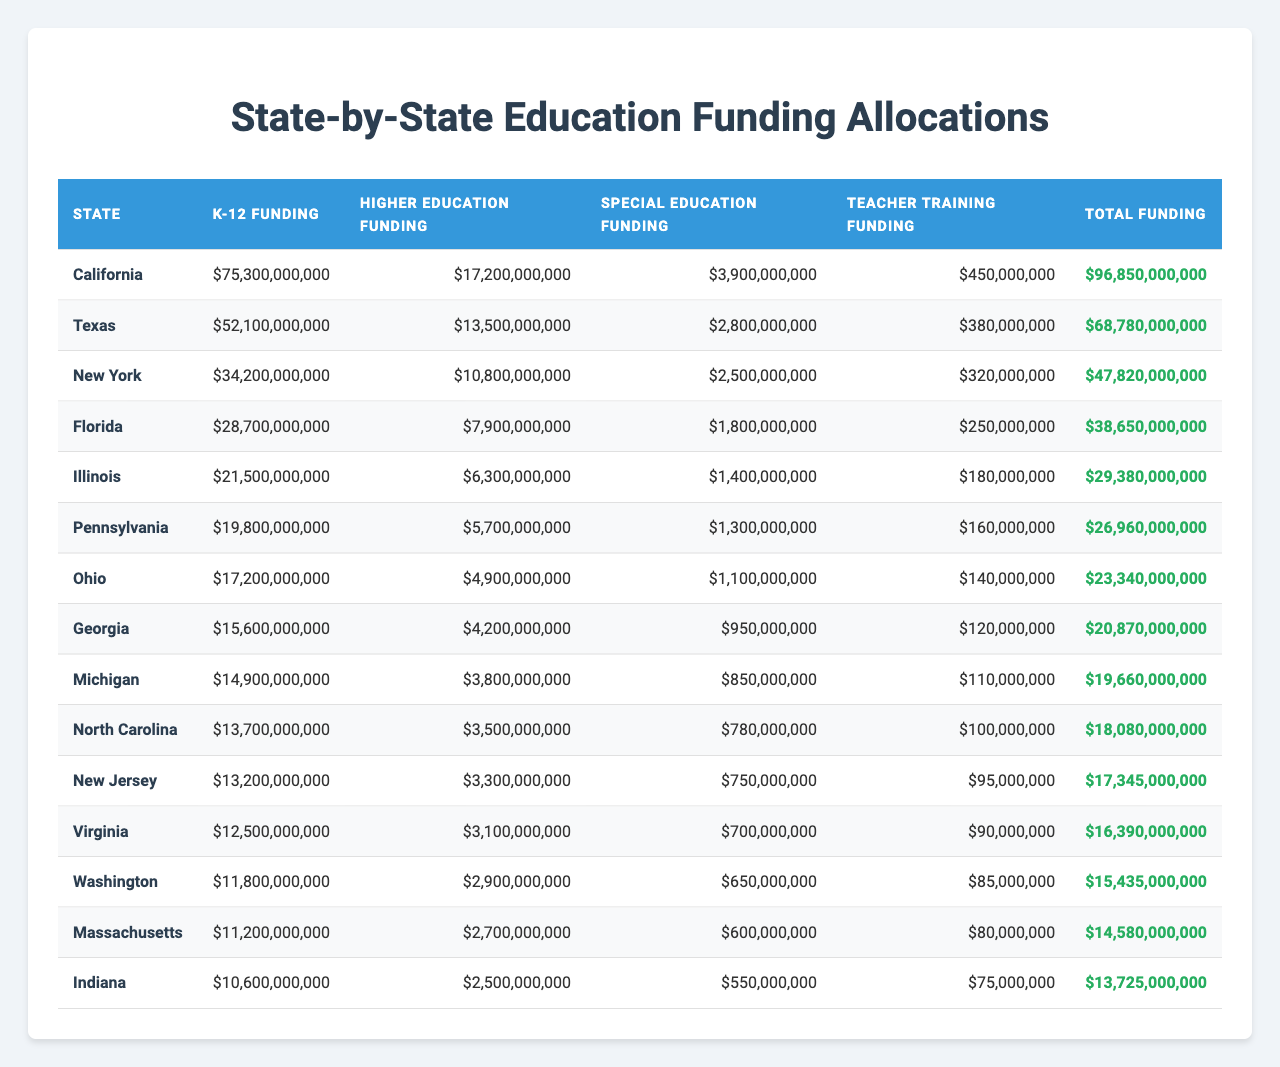What is the total K-12 funding for California? According to the table, California's K-12 funding is listed as $75,300,000,000.
Answer: $75,300,000,000 Which state has the highest total funding? By examining the 'Total Funding' column, California's total funding of $96,850,000,000 is higher than any other state listed.
Answer: California What is the sum of Special Education Funding in Texas and Florida? Texas has $2,800,000,000 in Special Education Funding and Florida has $1,800,000,000. Summing these amounts gives $2,800,000,000 + $1,800,000,000 = $4,600,000,000.
Answer: $4,600,000,000 Is the Higher Education Funding for North Carolina greater than that for Indiana? North Carolina's Higher Education Funding is $3,500,000,000 while Indiana's is $2,500,000,000, meaning North Carolina's funding is indeed greater.
Answer: Yes What is the average K-12 funding across all the states listed? To find the average, we sum all K-12 fundings: $75,300,000,000 + $52,100,000,000 + $34,200,000,000 + $28,700,000,000 + $21,500,000,000 + $19,800,000,000 + $17,200,000,000 + $15,600,000,000 + $14,900,000,000 + $13,700,000,000 + $13,200,000,000 + $12,500,000,000 + $11,800,000,000 + $11,200,000,000 + $10,600,000,000 = $481,300,000,000. There are 15 states, so the average is $481,300,000,000 / 15 = $32,086,666,667.
Answer: $32,086,666,667 Which two states have the closest total funding amounts, and what are those amounts? By reviewing the 'Total Funding' figures, Virginia has $16,390,000,000 and New Jersey has $17,345,000,000. The difference is $955,000,000, which indicates these amounts are the closest.
Answer: Virginia and New Jersey; $16,390,000,000 and $17,345,000,000 How much more is the Higher Education Funding in New York compared to Illinois? The Higher Education Funding for New York is $10,800,000,000, and for Illinois, it is $6,300,000,000. The difference is $10,800,000,000 - $6,300,000,000 = $4,500,000,000.
Answer: $4,500,000,000 Does the total funding for Michigan exceed that of Ohio? Michigan's total funding is $19,660,000,000, while Ohio's total funding is $23,340,000,000. Since $19,660,000,000 is less than $23,340,000,000, the statement is false.
Answer: No What is the total amount allocated for Teacher Training Funding across all states? Summing the Teacher Training Funding amounts: $450,000,000 (California) + $380,000,000 (Texas) + $320,000,000 (New York) + $250,000,000 (Florida) + $180,000,000 (Illinois) + $160,000,000 (Pennsylvania) + $140,000,000 (Ohio) + $120,000,000 (Georgia) + $110,000,000 (Michigan) + $100,000,000 (North Carolina) + $95,000,000 (New Jersey) + $90,000,000 (Virginia) + $85,000,000 (Washington) + $80,000,000 (Massachusetts) + $75,000,000 (Indiana) = $2,670,000,000.
Answer: $2,670,000,000 What percentage of total funding in Texas is allocated to K-12 education? Texas' total funding is $68,780,000,000, and K-12 funding is $52,100,000,000. The percentage is calculated as ($52,100,000,000 / $68,780,000,000) * 100 = 75.8%.
Answer: 75.8% 